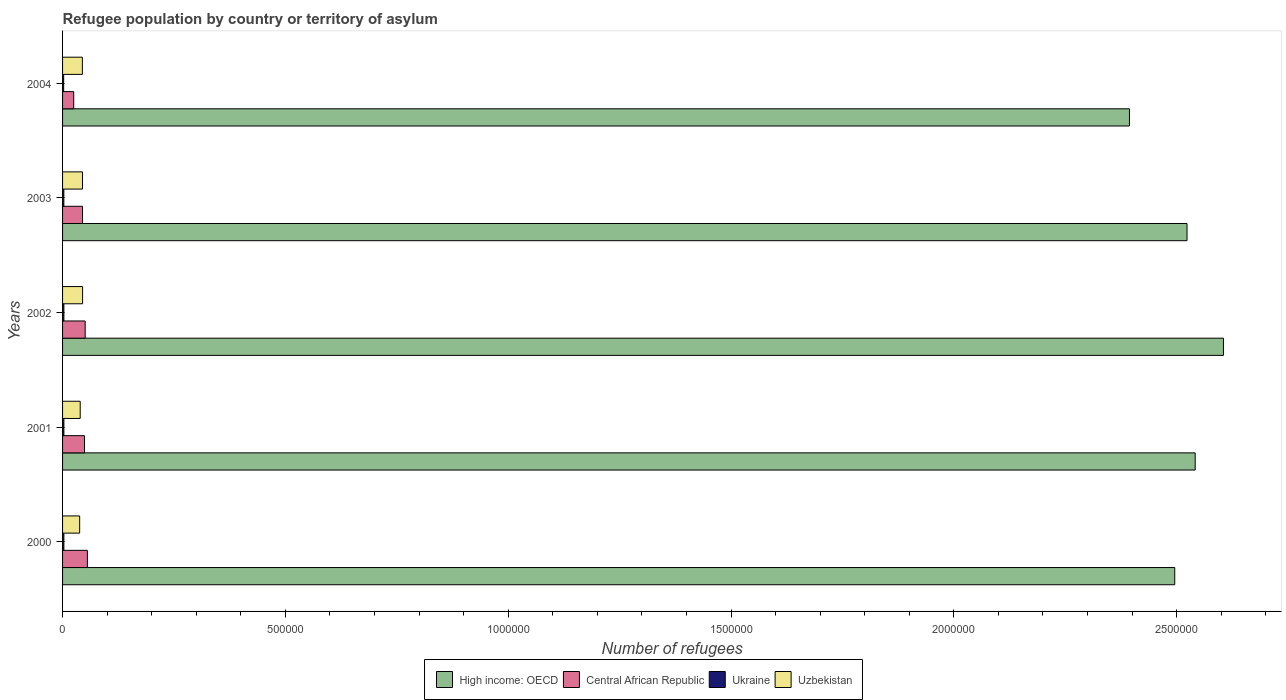How many different coloured bars are there?
Offer a very short reply. 4. How many groups of bars are there?
Your answer should be compact. 5. Are the number of bars per tick equal to the number of legend labels?
Your answer should be very brief. Yes. In how many cases, is the number of bars for a given year not equal to the number of legend labels?
Keep it short and to the point. 0. What is the number of refugees in Uzbekistan in 2000?
Your answer should be very brief. 3.84e+04. Across all years, what is the maximum number of refugees in Ukraine?
Provide a succinct answer. 2983. Across all years, what is the minimum number of refugees in Ukraine?
Your answer should be very brief. 2459. In which year was the number of refugees in High income: OECD minimum?
Make the answer very short. 2004. What is the total number of refugees in Central African Republic in the graph?
Your answer should be very brief. 2.25e+05. What is the difference between the number of refugees in Central African Republic in 2002 and that in 2004?
Your answer should be very brief. 2.57e+04. What is the difference between the number of refugees in Ukraine in 2000 and the number of refugees in High income: OECD in 2001?
Keep it short and to the point. -2.54e+06. What is the average number of refugees in Ukraine per year?
Offer a very short reply. 2847.2. In the year 2003, what is the difference between the number of refugees in Central African Republic and number of refugees in Ukraine?
Your answer should be compact. 4.19e+04. In how many years, is the number of refugees in Ukraine greater than 200000 ?
Your answer should be very brief. 0. What is the ratio of the number of refugees in Ukraine in 2002 to that in 2004?
Make the answer very short. 1.21. Is the number of refugees in High income: OECD in 2003 less than that in 2004?
Give a very brief answer. No. What is the difference between the highest and the second highest number of refugees in Uzbekistan?
Your answer should be compact. 254. What is the difference between the highest and the lowest number of refugees in Uzbekistan?
Ensure brevity in your answer.  6586. In how many years, is the number of refugees in High income: OECD greater than the average number of refugees in High income: OECD taken over all years?
Your answer should be very brief. 3. What does the 1st bar from the top in 2000 represents?
Ensure brevity in your answer.  Uzbekistan. What does the 1st bar from the bottom in 2004 represents?
Ensure brevity in your answer.  High income: OECD. Is it the case that in every year, the sum of the number of refugees in Central African Republic and number of refugees in High income: OECD is greater than the number of refugees in Ukraine?
Offer a terse response. Yes. How many bars are there?
Your response must be concise. 20. Are all the bars in the graph horizontal?
Ensure brevity in your answer.  Yes. How many years are there in the graph?
Ensure brevity in your answer.  5. What is the difference between two consecutive major ticks on the X-axis?
Make the answer very short. 5.00e+05. Where does the legend appear in the graph?
Your answer should be very brief. Bottom center. How are the legend labels stacked?
Provide a succinct answer. Horizontal. What is the title of the graph?
Make the answer very short. Refugee population by country or territory of asylum. Does "Lower middle income" appear as one of the legend labels in the graph?
Offer a terse response. No. What is the label or title of the X-axis?
Your answer should be very brief. Number of refugees. What is the Number of refugees of High income: OECD in 2000?
Your answer should be compact. 2.50e+06. What is the Number of refugees in Central African Republic in 2000?
Offer a very short reply. 5.57e+04. What is the Number of refugees in Ukraine in 2000?
Offer a terse response. 2951. What is the Number of refugees in Uzbekistan in 2000?
Provide a short and direct response. 3.84e+04. What is the Number of refugees of High income: OECD in 2001?
Offer a terse response. 2.54e+06. What is the Number of refugees in Central African Republic in 2001?
Keep it short and to the point. 4.92e+04. What is the Number of refugees in Ukraine in 2001?
Offer a terse response. 2983. What is the Number of refugees in Uzbekistan in 2001?
Keep it short and to the point. 3.96e+04. What is the Number of refugees in High income: OECD in 2002?
Offer a terse response. 2.61e+06. What is the Number of refugees of Central African Republic in 2002?
Your response must be concise. 5.07e+04. What is the Number of refugees of Ukraine in 2002?
Your answer should be very brief. 2966. What is the Number of refugees of Uzbekistan in 2002?
Your response must be concise. 4.49e+04. What is the Number of refugees of High income: OECD in 2003?
Offer a very short reply. 2.52e+06. What is the Number of refugees in Central African Republic in 2003?
Offer a very short reply. 4.48e+04. What is the Number of refugees in Ukraine in 2003?
Provide a short and direct response. 2877. What is the Number of refugees in Uzbekistan in 2003?
Keep it short and to the point. 4.47e+04. What is the Number of refugees of High income: OECD in 2004?
Your answer should be compact. 2.39e+06. What is the Number of refugees in Central African Republic in 2004?
Provide a short and direct response. 2.50e+04. What is the Number of refugees of Ukraine in 2004?
Your answer should be very brief. 2459. What is the Number of refugees of Uzbekistan in 2004?
Provide a succinct answer. 4.45e+04. Across all years, what is the maximum Number of refugees of High income: OECD?
Your response must be concise. 2.61e+06. Across all years, what is the maximum Number of refugees of Central African Republic?
Offer a terse response. 5.57e+04. Across all years, what is the maximum Number of refugees of Ukraine?
Give a very brief answer. 2983. Across all years, what is the maximum Number of refugees in Uzbekistan?
Provide a succinct answer. 4.49e+04. Across all years, what is the minimum Number of refugees of High income: OECD?
Provide a short and direct response. 2.39e+06. Across all years, what is the minimum Number of refugees in Central African Republic?
Your answer should be very brief. 2.50e+04. Across all years, what is the minimum Number of refugees of Ukraine?
Your response must be concise. 2459. Across all years, what is the minimum Number of refugees of Uzbekistan?
Provide a succinct answer. 3.84e+04. What is the total Number of refugees in High income: OECD in the graph?
Ensure brevity in your answer.  1.26e+07. What is the total Number of refugees in Central African Republic in the graph?
Give a very brief answer. 2.25e+05. What is the total Number of refugees of Ukraine in the graph?
Give a very brief answer. 1.42e+04. What is the total Number of refugees of Uzbekistan in the graph?
Make the answer very short. 2.12e+05. What is the difference between the Number of refugees of High income: OECD in 2000 and that in 2001?
Your answer should be very brief. -4.59e+04. What is the difference between the Number of refugees of Central African Republic in 2000 and that in 2001?
Your response must be concise. 6422. What is the difference between the Number of refugees of Ukraine in 2000 and that in 2001?
Make the answer very short. -32. What is the difference between the Number of refugees of Uzbekistan in 2000 and that in 2001?
Provide a succinct answer. -1229. What is the difference between the Number of refugees of High income: OECD in 2000 and that in 2002?
Make the answer very short. -1.09e+05. What is the difference between the Number of refugees in Central African Republic in 2000 and that in 2002?
Provide a succinct answer. 4936. What is the difference between the Number of refugees in Ukraine in 2000 and that in 2002?
Make the answer very short. -15. What is the difference between the Number of refugees in Uzbekistan in 2000 and that in 2002?
Offer a terse response. -6586. What is the difference between the Number of refugees in High income: OECD in 2000 and that in 2003?
Keep it short and to the point. -2.76e+04. What is the difference between the Number of refugees of Central African Republic in 2000 and that in 2003?
Keep it short and to the point. 1.09e+04. What is the difference between the Number of refugees of Ukraine in 2000 and that in 2003?
Make the answer very short. 74. What is the difference between the Number of refugees of Uzbekistan in 2000 and that in 2003?
Give a very brief answer. -6332. What is the difference between the Number of refugees of High income: OECD in 2000 and that in 2004?
Give a very brief answer. 1.02e+05. What is the difference between the Number of refugees in Central African Republic in 2000 and that in 2004?
Offer a very short reply. 3.06e+04. What is the difference between the Number of refugees of Ukraine in 2000 and that in 2004?
Offer a very short reply. 492. What is the difference between the Number of refugees of Uzbekistan in 2000 and that in 2004?
Give a very brief answer. -6105. What is the difference between the Number of refugees in High income: OECD in 2001 and that in 2002?
Your answer should be very brief. -6.34e+04. What is the difference between the Number of refugees of Central African Republic in 2001 and that in 2002?
Offer a terse response. -1486. What is the difference between the Number of refugees in Uzbekistan in 2001 and that in 2002?
Offer a very short reply. -5357. What is the difference between the Number of refugees of High income: OECD in 2001 and that in 2003?
Keep it short and to the point. 1.83e+04. What is the difference between the Number of refugees in Central African Republic in 2001 and that in 2003?
Give a very brief answer. 4486. What is the difference between the Number of refugees in Ukraine in 2001 and that in 2003?
Your answer should be compact. 106. What is the difference between the Number of refugees of Uzbekistan in 2001 and that in 2003?
Ensure brevity in your answer.  -5103. What is the difference between the Number of refugees of High income: OECD in 2001 and that in 2004?
Your answer should be compact. 1.47e+05. What is the difference between the Number of refugees of Central African Republic in 2001 and that in 2004?
Your answer should be compact. 2.42e+04. What is the difference between the Number of refugees in Ukraine in 2001 and that in 2004?
Offer a very short reply. 524. What is the difference between the Number of refugees of Uzbekistan in 2001 and that in 2004?
Ensure brevity in your answer.  -4876. What is the difference between the Number of refugees of High income: OECD in 2002 and that in 2003?
Your answer should be very brief. 8.17e+04. What is the difference between the Number of refugees of Central African Republic in 2002 and that in 2003?
Make the answer very short. 5972. What is the difference between the Number of refugees of Ukraine in 2002 and that in 2003?
Make the answer very short. 89. What is the difference between the Number of refugees of Uzbekistan in 2002 and that in 2003?
Your answer should be compact. 254. What is the difference between the Number of refugees of High income: OECD in 2002 and that in 2004?
Provide a short and direct response. 2.11e+05. What is the difference between the Number of refugees in Central African Republic in 2002 and that in 2004?
Provide a succinct answer. 2.57e+04. What is the difference between the Number of refugees of Ukraine in 2002 and that in 2004?
Keep it short and to the point. 507. What is the difference between the Number of refugees of Uzbekistan in 2002 and that in 2004?
Your answer should be very brief. 481. What is the difference between the Number of refugees of High income: OECD in 2003 and that in 2004?
Provide a succinct answer. 1.29e+05. What is the difference between the Number of refugees of Central African Republic in 2003 and that in 2004?
Provide a short and direct response. 1.97e+04. What is the difference between the Number of refugees of Ukraine in 2003 and that in 2004?
Keep it short and to the point. 418. What is the difference between the Number of refugees of Uzbekistan in 2003 and that in 2004?
Make the answer very short. 227. What is the difference between the Number of refugees in High income: OECD in 2000 and the Number of refugees in Central African Republic in 2001?
Make the answer very short. 2.45e+06. What is the difference between the Number of refugees of High income: OECD in 2000 and the Number of refugees of Ukraine in 2001?
Your answer should be compact. 2.49e+06. What is the difference between the Number of refugees in High income: OECD in 2000 and the Number of refugees in Uzbekistan in 2001?
Your response must be concise. 2.46e+06. What is the difference between the Number of refugees of Central African Republic in 2000 and the Number of refugees of Ukraine in 2001?
Provide a succinct answer. 5.27e+04. What is the difference between the Number of refugees in Central African Republic in 2000 and the Number of refugees in Uzbekistan in 2001?
Keep it short and to the point. 1.61e+04. What is the difference between the Number of refugees of Ukraine in 2000 and the Number of refugees of Uzbekistan in 2001?
Make the answer very short. -3.66e+04. What is the difference between the Number of refugees in High income: OECD in 2000 and the Number of refugees in Central African Republic in 2002?
Make the answer very short. 2.45e+06. What is the difference between the Number of refugees in High income: OECD in 2000 and the Number of refugees in Ukraine in 2002?
Keep it short and to the point. 2.49e+06. What is the difference between the Number of refugees of High income: OECD in 2000 and the Number of refugees of Uzbekistan in 2002?
Offer a terse response. 2.45e+06. What is the difference between the Number of refugees in Central African Republic in 2000 and the Number of refugees in Ukraine in 2002?
Your response must be concise. 5.27e+04. What is the difference between the Number of refugees of Central African Republic in 2000 and the Number of refugees of Uzbekistan in 2002?
Provide a succinct answer. 1.07e+04. What is the difference between the Number of refugees in Ukraine in 2000 and the Number of refugees in Uzbekistan in 2002?
Keep it short and to the point. -4.20e+04. What is the difference between the Number of refugees in High income: OECD in 2000 and the Number of refugees in Central African Republic in 2003?
Your response must be concise. 2.45e+06. What is the difference between the Number of refugees in High income: OECD in 2000 and the Number of refugees in Ukraine in 2003?
Give a very brief answer. 2.49e+06. What is the difference between the Number of refugees in High income: OECD in 2000 and the Number of refugees in Uzbekistan in 2003?
Provide a short and direct response. 2.45e+06. What is the difference between the Number of refugees in Central African Republic in 2000 and the Number of refugees in Ukraine in 2003?
Offer a terse response. 5.28e+04. What is the difference between the Number of refugees in Central African Republic in 2000 and the Number of refugees in Uzbekistan in 2003?
Your answer should be compact. 1.10e+04. What is the difference between the Number of refugees of Ukraine in 2000 and the Number of refugees of Uzbekistan in 2003?
Your response must be concise. -4.17e+04. What is the difference between the Number of refugees in High income: OECD in 2000 and the Number of refugees in Central African Republic in 2004?
Offer a very short reply. 2.47e+06. What is the difference between the Number of refugees in High income: OECD in 2000 and the Number of refugees in Ukraine in 2004?
Keep it short and to the point. 2.49e+06. What is the difference between the Number of refugees in High income: OECD in 2000 and the Number of refugees in Uzbekistan in 2004?
Offer a terse response. 2.45e+06. What is the difference between the Number of refugees of Central African Republic in 2000 and the Number of refugees of Ukraine in 2004?
Ensure brevity in your answer.  5.32e+04. What is the difference between the Number of refugees in Central African Republic in 2000 and the Number of refugees in Uzbekistan in 2004?
Your answer should be compact. 1.12e+04. What is the difference between the Number of refugees in Ukraine in 2000 and the Number of refugees in Uzbekistan in 2004?
Make the answer very short. -4.15e+04. What is the difference between the Number of refugees in High income: OECD in 2001 and the Number of refugees in Central African Republic in 2002?
Make the answer very short. 2.49e+06. What is the difference between the Number of refugees of High income: OECD in 2001 and the Number of refugees of Ukraine in 2002?
Make the answer very short. 2.54e+06. What is the difference between the Number of refugees in High income: OECD in 2001 and the Number of refugees in Uzbekistan in 2002?
Your response must be concise. 2.50e+06. What is the difference between the Number of refugees in Central African Republic in 2001 and the Number of refugees in Ukraine in 2002?
Provide a succinct answer. 4.63e+04. What is the difference between the Number of refugees of Central African Republic in 2001 and the Number of refugees of Uzbekistan in 2002?
Offer a very short reply. 4303. What is the difference between the Number of refugees of Ukraine in 2001 and the Number of refugees of Uzbekistan in 2002?
Your answer should be very brief. -4.20e+04. What is the difference between the Number of refugees in High income: OECD in 2001 and the Number of refugees in Central African Republic in 2003?
Give a very brief answer. 2.50e+06. What is the difference between the Number of refugees in High income: OECD in 2001 and the Number of refugees in Ukraine in 2003?
Your answer should be compact. 2.54e+06. What is the difference between the Number of refugees of High income: OECD in 2001 and the Number of refugees of Uzbekistan in 2003?
Make the answer very short. 2.50e+06. What is the difference between the Number of refugees of Central African Republic in 2001 and the Number of refugees of Ukraine in 2003?
Offer a very short reply. 4.64e+04. What is the difference between the Number of refugees of Central African Republic in 2001 and the Number of refugees of Uzbekistan in 2003?
Your response must be concise. 4557. What is the difference between the Number of refugees in Ukraine in 2001 and the Number of refugees in Uzbekistan in 2003?
Provide a short and direct response. -4.17e+04. What is the difference between the Number of refugees of High income: OECD in 2001 and the Number of refugees of Central African Republic in 2004?
Your answer should be compact. 2.52e+06. What is the difference between the Number of refugees of High income: OECD in 2001 and the Number of refugees of Ukraine in 2004?
Give a very brief answer. 2.54e+06. What is the difference between the Number of refugees in High income: OECD in 2001 and the Number of refugees in Uzbekistan in 2004?
Keep it short and to the point. 2.50e+06. What is the difference between the Number of refugees of Central African Republic in 2001 and the Number of refugees of Ukraine in 2004?
Keep it short and to the point. 4.68e+04. What is the difference between the Number of refugees of Central African Republic in 2001 and the Number of refugees of Uzbekistan in 2004?
Make the answer very short. 4784. What is the difference between the Number of refugees in Ukraine in 2001 and the Number of refugees in Uzbekistan in 2004?
Your answer should be compact. -4.15e+04. What is the difference between the Number of refugees of High income: OECD in 2002 and the Number of refugees of Central African Republic in 2003?
Give a very brief answer. 2.56e+06. What is the difference between the Number of refugees of High income: OECD in 2002 and the Number of refugees of Ukraine in 2003?
Provide a short and direct response. 2.60e+06. What is the difference between the Number of refugees in High income: OECD in 2002 and the Number of refugees in Uzbekistan in 2003?
Ensure brevity in your answer.  2.56e+06. What is the difference between the Number of refugees of Central African Republic in 2002 and the Number of refugees of Ukraine in 2003?
Keep it short and to the point. 4.78e+04. What is the difference between the Number of refugees in Central African Republic in 2002 and the Number of refugees in Uzbekistan in 2003?
Give a very brief answer. 6043. What is the difference between the Number of refugees in Ukraine in 2002 and the Number of refugees in Uzbekistan in 2003?
Your answer should be compact. -4.17e+04. What is the difference between the Number of refugees in High income: OECD in 2002 and the Number of refugees in Central African Republic in 2004?
Ensure brevity in your answer.  2.58e+06. What is the difference between the Number of refugees in High income: OECD in 2002 and the Number of refugees in Ukraine in 2004?
Your answer should be very brief. 2.60e+06. What is the difference between the Number of refugees of High income: OECD in 2002 and the Number of refugees of Uzbekistan in 2004?
Keep it short and to the point. 2.56e+06. What is the difference between the Number of refugees in Central African Republic in 2002 and the Number of refugees in Ukraine in 2004?
Keep it short and to the point. 4.83e+04. What is the difference between the Number of refugees in Central African Republic in 2002 and the Number of refugees in Uzbekistan in 2004?
Keep it short and to the point. 6270. What is the difference between the Number of refugees of Ukraine in 2002 and the Number of refugees of Uzbekistan in 2004?
Your response must be concise. -4.15e+04. What is the difference between the Number of refugees in High income: OECD in 2003 and the Number of refugees in Central African Republic in 2004?
Offer a very short reply. 2.50e+06. What is the difference between the Number of refugees of High income: OECD in 2003 and the Number of refugees of Ukraine in 2004?
Provide a short and direct response. 2.52e+06. What is the difference between the Number of refugees of High income: OECD in 2003 and the Number of refugees of Uzbekistan in 2004?
Make the answer very short. 2.48e+06. What is the difference between the Number of refugees in Central African Republic in 2003 and the Number of refugees in Ukraine in 2004?
Your answer should be compact. 4.23e+04. What is the difference between the Number of refugees of Central African Republic in 2003 and the Number of refugees of Uzbekistan in 2004?
Offer a terse response. 298. What is the difference between the Number of refugees in Ukraine in 2003 and the Number of refugees in Uzbekistan in 2004?
Your answer should be compact. -4.16e+04. What is the average Number of refugees in High income: OECD per year?
Your answer should be compact. 2.51e+06. What is the average Number of refugees in Central African Republic per year?
Provide a short and direct response. 4.51e+04. What is the average Number of refugees of Ukraine per year?
Provide a succinct answer. 2847.2. What is the average Number of refugees of Uzbekistan per year?
Offer a terse response. 4.24e+04. In the year 2000, what is the difference between the Number of refugees of High income: OECD and Number of refugees of Central African Republic?
Your answer should be compact. 2.44e+06. In the year 2000, what is the difference between the Number of refugees in High income: OECD and Number of refugees in Ukraine?
Provide a short and direct response. 2.49e+06. In the year 2000, what is the difference between the Number of refugees in High income: OECD and Number of refugees in Uzbekistan?
Give a very brief answer. 2.46e+06. In the year 2000, what is the difference between the Number of refugees of Central African Republic and Number of refugees of Ukraine?
Ensure brevity in your answer.  5.27e+04. In the year 2000, what is the difference between the Number of refugees in Central African Republic and Number of refugees in Uzbekistan?
Offer a very short reply. 1.73e+04. In the year 2000, what is the difference between the Number of refugees of Ukraine and Number of refugees of Uzbekistan?
Offer a very short reply. -3.54e+04. In the year 2001, what is the difference between the Number of refugees of High income: OECD and Number of refugees of Central African Republic?
Your answer should be compact. 2.49e+06. In the year 2001, what is the difference between the Number of refugees of High income: OECD and Number of refugees of Ukraine?
Ensure brevity in your answer.  2.54e+06. In the year 2001, what is the difference between the Number of refugees of High income: OECD and Number of refugees of Uzbekistan?
Provide a succinct answer. 2.50e+06. In the year 2001, what is the difference between the Number of refugees of Central African Republic and Number of refugees of Ukraine?
Make the answer very short. 4.63e+04. In the year 2001, what is the difference between the Number of refugees in Central African Republic and Number of refugees in Uzbekistan?
Your answer should be very brief. 9660. In the year 2001, what is the difference between the Number of refugees of Ukraine and Number of refugees of Uzbekistan?
Keep it short and to the point. -3.66e+04. In the year 2002, what is the difference between the Number of refugees in High income: OECD and Number of refugees in Central African Republic?
Make the answer very short. 2.55e+06. In the year 2002, what is the difference between the Number of refugees of High income: OECD and Number of refugees of Ukraine?
Make the answer very short. 2.60e+06. In the year 2002, what is the difference between the Number of refugees of High income: OECD and Number of refugees of Uzbekistan?
Your answer should be very brief. 2.56e+06. In the year 2002, what is the difference between the Number of refugees of Central African Republic and Number of refugees of Ukraine?
Your response must be concise. 4.78e+04. In the year 2002, what is the difference between the Number of refugees in Central African Republic and Number of refugees in Uzbekistan?
Ensure brevity in your answer.  5789. In the year 2002, what is the difference between the Number of refugees of Ukraine and Number of refugees of Uzbekistan?
Provide a succinct answer. -4.20e+04. In the year 2003, what is the difference between the Number of refugees of High income: OECD and Number of refugees of Central African Republic?
Your answer should be compact. 2.48e+06. In the year 2003, what is the difference between the Number of refugees of High income: OECD and Number of refugees of Ukraine?
Provide a succinct answer. 2.52e+06. In the year 2003, what is the difference between the Number of refugees of High income: OECD and Number of refugees of Uzbekistan?
Give a very brief answer. 2.48e+06. In the year 2003, what is the difference between the Number of refugees of Central African Republic and Number of refugees of Ukraine?
Provide a succinct answer. 4.19e+04. In the year 2003, what is the difference between the Number of refugees in Central African Republic and Number of refugees in Uzbekistan?
Offer a very short reply. 71. In the year 2003, what is the difference between the Number of refugees in Ukraine and Number of refugees in Uzbekistan?
Make the answer very short. -4.18e+04. In the year 2004, what is the difference between the Number of refugees in High income: OECD and Number of refugees in Central African Republic?
Your answer should be compact. 2.37e+06. In the year 2004, what is the difference between the Number of refugees of High income: OECD and Number of refugees of Ukraine?
Your answer should be very brief. 2.39e+06. In the year 2004, what is the difference between the Number of refugees in High income: OECD and Number of refugees in Uzbekistan?
Give a very brief answer. 2.35e+06. In the year 2004, what is the difference between the Number of refugees of Central African Republic and Number of refugees of Ukraine?
Provide a short and direct response. 2.26e+04. In the year 2004, what is the difference between the Number of refugees of Central African Republic and Number of refugees of Uzbekistan?
Your response must be concise. -1.94e+04. In the year 2004, what is the difference between the Number of refugees in Ukraine and Number of refugees in Uzbekistan?
Make the answer very short. -4.20e+04. What is the ratio of the Number of refugees in High income: OECD in 2000 to that in 2001?
Offer a very short reply. 0.98. What is the ratio of the Number of refugees of Central African Republic in 2000 to that in 2001?
Give a very brief answer. 1.13. What is the ratio of the Number of refugees in Ukraine in 2000 to that in 2001?
Make the answer very short. 0.99. What is the ratio of the Number of refugees of Uzbekistan in 2000 to that in 2001?
Make the answer very short. 0.97. What is the ratio of the Number of refugees of High income: OECD in 2000 to that in 2002?
Make the answer very short. 0.96. What is the ratio of the Number of refugees of Central African Republic in 2000 to that in 2002?
Your answer should be very brief. 1.1. What is the ratio of the Number of refugees in Uzbekistan in 2000 to that in 2002?
Provide a succinct answer. 0.85. What is the ratio of the Number of refugees in Central African Republic in 2000 to that in 2003?
Your answer should be very brief. 1.24. What is the ratio of the Number of refugees in Ukraine in 2000 to that in 2003?
Provide a succinct answer. 1.03. What is the ratio of the Number of refugees in Uzbekistan in 2000 to that in 2003?
Your answer should be compact. 0.86. What is the ratio of the Number of refugees of High income: OECD in 2000 to that in 2004?
Provide a short and direct response. 1.04. What is the ratio of the Number of refugees of Central African Republic in 2000 to that in 2004?
Your answer should be very brief. 2.22. What is the ratio of the Number of refugees of Ukraine in 2000 to that in 2004?
Provide a short and direct response. 1.2. What is the ratio of the Number of refugees of Uzbekistan in 2000 to that in 2004?
Keep it short and to the point. 0.86. What is the ratio of the Number of refugees in High income: OECD in 2001 to that in 2002?
Your answer should be very brief. 0.98. What is the ratio of the Number of refugees in Central African Republic in 2001 to that in 2002?
Your answer should be compact. 0.97. What is the ratio of the Number of refugees of Uzbekistan in 2001 to that in 2002?
Make the answer very short. 0.88. What is the ratio of the Number of refugees in High income: OECD in 2001 to that in 2003?
Give a very brief answer. 1.01. What is the ratio of the Number of refugees in Central African Republic in 2001 to that in 2003?
Make the answer very short. 1.1. What is the ratio of the Number of refugees in Ukraine in 2001 to that in 2003?
Offer a very short reply. 1.04. What is the ratio of the Number of refugees in Uzbekistan in 2001 to that in 2003?
Give a very brief answer. 0.89. What is the ratio of the Number of refugees in High income: OECD in 2001 to that in 2004?
Provide a succinct answer. 1.06. What is the ratio of the Number of refugees of Central African Republic in 2001 to that in 2004?
Your answer should be very brief. 1.97. What is the ratio of the Number of refugees in Ukraine in 2001 to that in 2004?
Give a very brief answer. 1.21. What is the ratio of the Number of refugees in Uzbekistan in 2001 to that in 2004?
Provide a short and direct response. 0.89. What is the ratio of the Number of refugees of High income: OECD in 2002 to that in 2003?
Offer a very short reply. 1.03. What is the ratio of the Number of refugees in Central African Republic in 2002 to that in 2003?
Keep it short and to the point. 1.13. What is the ratio of the Number of refugees of Ukraine in 2002 to that in 2003?
Your answer should be very brief. 1.03. What is the ratio of the Number of refugees of High income: OECD in 2002 to that in 2004?
Ensure brevity in your answer.  1.09. What is the ratio of the Number of refugees in Central African Republic in 2002 to that in 2004?
Keep it short and to the point. 2.03. What is the ratio of the Number of refugees of Ukraine in 2002 to that in 2004?
Provide a succinct answer. 1.21. What is the ratio of the Number of refugees in Uzbekistan in 2002 to that in 2004?
Provide a short and direct response. 1.01. What is the ratio of the Number of refugees of High income: OECD in 2003 to that in 2004?
Your answer should be compact. 1.05. What is the ratio of the Number of refugees in Central African Republic in 2003 to that in 2004?
Offer a very short reply. 1.79. What is the ratio of the Number of refugees in Ukraine in 2003 to that in 2004?
Ensure brevity in your answer.  1.17. What is the ratio of the Number of refugees in Uzbekistan in 2003 to that in 2004?
Provide a short and direct response. 1.01. What is the difference between the highest and the second highest Number of refugees of High income: OECD?
Provide a short and direct response. 6.34e+04. What is the difference between the highest and the second highest Number of refugees of Central African Republic?
Ensure brevity in your answer.  4936. What is the difference between the highest and the second highest Number of refugees in Uzbekistan?
Make the answer very short. 254. What is the difference between the highest and the lowest Number of refugees in High income: OECD?
Offer a terse response. 2.11e+05. What is the difference between the highest and the lowest Number of refugees of Central African Republic?
Your answer should be very brief. 3.06e+04. What is the difference between the highest and the lowest Number of refugees of Ukraine?
Your answer should be very brief. 524. What is the difference between the highest and the lowest Number of refugees of Uzbekistan?
Your answer should be compact. 6586. 